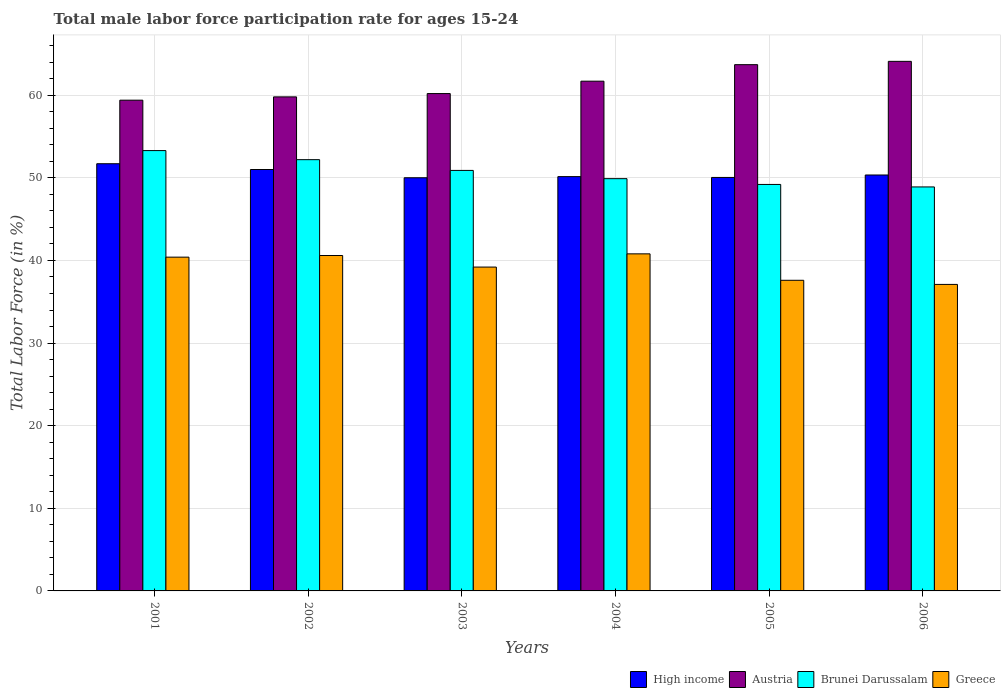How many different coloured bars are there?
Give a very brief answer. 4. How many groups of bars are there?
Offer a terse response. 6. Are the number of bars on each tick of the X-axis equal?
Your response must be concise. Yes. What is the label of the 3rd group of bars from the left?
Provide a short and direct response. 2003. What is the male labor force participation rate in Greece in 2006?
Ensure brevity in your answer.  37.1. Across all years, what is the maximum male labor force participation rate in High income?
Your response must be concise. 51.71. Across all years, what is the minimum male labor force participation rate in High income?
Offer a very short reply. 50.01. What is the total male labor force participation rate in High income in the graph?
Ensure brevity in your answer.  303.27. What is the difference between the male labor force participation rate in Greece in 2003 and that in 2005?
Your answer should be very brief. 1.6. What is the difference between the male labor force participation rate in High income in 2005 and the male labor force participation rate in Greece in 2002?
Your answer should be compact. 9.45. What is the average male labor force participation rate in High income per year?
Provide a short and direct response. 50.54. In the year 2001, what is the difference between the male labor force participation rate in Greece and male labor force participation rate in Brunei Darussalam?
Offer a very short reply. -12.9. In how many years, is the male labor force participation rate in High income greater than 58 %?
Give a very brief answer. 0. What is the ratio of the male labor force participation rate in Greece in 2001 to that in 2003?
Give a very brief answer. 1.03. Is the difference between the male labor force participation rate in Greece in 2001 and 2005 greater than the difference between the male labor force participation rate in Brunei Darussalam in 2001 and 2005?
Your response must be concise. No. What is the difference between the highest and the second highest male labor force participation rate in Brunei Darussalam?
Make the answer very short. 1.1. What is the difference between the highest and the lowest male labor force participation rate in Brunei Darussalam?
Give a very brief answer. 4.4. In how many years, is the male labor force participation rate in Austria greater than the average male labor force participation rate in Austria taken over all years?
Make the answer very short. 3. What does the 4th bar from the left in 2003 represents?
Offer a terse response. Greece. Is it the case that in every year, the sum of the male labor force participation rate in Greece and male labor force participation rate in Brunei Darussalam is greater than the male labor force participation rate in High income?
Your response must be concise. Yes. How many bars are there?
Give a very brief answer. 24. Are all the bars in the graph horizontal?
Offer a very short reply. No. How many years are there in the graph?
Offer a terse response. 6. What is the difference between two consecutive major ticks on the Y-axis?
Your answer should be very brief. 10. Are the values on the major ticks of Y-axis written in scientific E-notation?
Make the answer very short. No. How are the legend labels stacked?
Provide a succinct answer. Horizontal. What is the title of the graph?
Your answer should be very brief. Total male labor force participation rate for ages 15-24. Does "Sub-Saharan Africa (all income levels)" appear as one of the legend labels in the graph?
Your answer should be compact. No. What is the label or title of the Y-axis?
Give a very brief answer. Total Labor Force (in %). What is the Total Labor Force (in %) in High income in 2001?
Offer a very short reply. 51.71. What is the Total Labor Force (in %) of Austria in 2001?
Give a very brief answer. 59.4. What is the Total Labor Force (in %) of Brunei Darussalam in 2001?
Make the answer very short. 53.3. What is the Total Labor Force (in %) of Greece in 2001?
Offer a terse response. 40.4. What is the Total Labor Force (in %) of High income in 2002?
Ensure brevity in your answer.  51.01. What is the Total Labor Force (in %) of Austria in 2002?
Provide a short and direct response. 59.8. What is the Total Labor Force (in %) of Brunei Darussalam in 2002?
Your answer should be compact. 52.2. What is the Total Labor Force (in %) in Greece in 2002?
Provide a succinct answer. 40.6. What is the Total Labor Force (in %) in High income in 2003?
Provide a short and direct response. 50.01. What is the Total Labor Force (in %) of Austria in 2003?
Your answer should be very brief. 60.2. What is the Total Labor Force (in %) of Brunei Darussalam in 2003?
Your answer should be very brief. 50.9. What is the Total Labor Force (in %) in Greece in 2003?
Your response must be concise. 39.2. What is the Total Labor Force (in %) of High income in 2004?
Provide a short and direct response. 50.15. What is the Total Labor Force (in %) in Austria in 2004?
Your response must be concise. 61.7. What is the Total Labor Force (in %) in Brunei Darussalam in 2004?
Make the answer very short. 49.9. What is the Total Labor Force (in %) of Greece in 2004?
Offer a very short reply. 40.8. What is the Total Labor Force (in %) in High income in 2005?
Provide a succinct answer. 50.05. What is the Total Labor Force (in %) in Austria in 2005?
Give a very brief answer. 63.7. What is the Total Labor Force (in %) of Brunei Darussalam in 2005?
Offer a very short reply. 49.2. What is the Total Labor Force (in %) of Greece in 2005?
Your answer should be compact. 37.6. What is the Total Labor Force (in %) of High income in 2006?
Offer a terse response. 50.35. What is the Total Labor Force (in %) of Austria in 2006?
Make the answer very short. 64.1. What is the Total Labor Force (in %) in Brunei Darussalam in 2006?
Ensure brevity in your answer.  48.9. What is the Total Labor Force (in %) of Greece in 2006?
Your answer should be compact. 37.1. Across all years, what is the maximum Total Labor Force (in %) in High income?
Offer a very short reply. 51.71. Across all years, what is the maximum Total Labor Force (in %) of Austria?
Give a very brief answer. 64.1. Across all years, what is the maximum Total Labor Force (in %) in Brunei Darussalam?
Provide a succinct answer. 53.3. Across all years, what is the maximum Total Labor Force (in %) of Greece?
Ensure brevity in your answer.  40.8. Across all years, what is the minimum Total Labor Force (in %) in High income?
Provide a succinct answer. 50.01. Across all years, what is the minimum Total Labor Force (in %) in Austria?
Your answer should be very brief. 59.4. Across all years, what is the minimum Total Labor Force (in %) in Brunei Darussalam?
Offer a terse response. 48.9. Across all years, what is the minimum Total Labor Force (in %) of Greece?
Offer a very short reply. 37.1. What is the total Total Labor Force (in %) of High income in the graph?
Make the answer very short. 303.27. What is the total Total Labor Force (in %) in Austria in the graph?
Provide a short and direct response. 368.9. What is the total Total Labor Force (in %) in Brunei Darussalam in the graph?
Provide a succinct answer. 304.4. What is the total Total Labor Force (in %) in Greece in the graph?
Make the answer very short. 235.7. What is the difference between the Total Labor Force (in %) in High income in 2001 and that in 2002?
Give a very brief answer. 0.7. What is the difference between the Total Labor Force (in %) in High income in 2001 and that in 2003?
Make the answer very short. 1.7. What is the difference between the Total Labor Force (in %) of High income in 2001 and that in 2004?
Your response must be concise. 1.56. What is the difference between the Total Labor Force (in %) in High income in 2001 and that in 2005?
Provide a succinct answer. 1.66. What is the difference between the Total Labor Force (in %) of Brunei Darussalam in 2001 and that in 2005?
Make the answer very short. 4.1. What is the difference between the Total Labor Force (in %) of High income in 2001 and that in 2006?
Keep it short and to the point. 1.36. What is the difference between the Total Labor Force (in %) in Brunei Darussalam in 2001 and that in 2006?
Ensure brevity in your answer.  4.4. What is the difference between the Total Labor Force (in %) of Greece in 2001 and that in 2006?
Provide a short and direct response. 3.3. What is the difference between the Total Labor Force (in %) of High income in 2002 and that in 2004?
Keep it short and to the point. 0.86. What is the difference between the Total Labor Force (in %) in High income in 2002 and that in 2005?
Provide a succinct answer. 0.96. What is the difference between the Total Labor Force (in %) of Greece in 2002 and that in 2005?
Your answer should be very brief. 3. What is the difference between the Total Labor Force (in %) in High income in 2002 and that in 2006?
Provide a succinct answer. 0.66. What is the difference between the Total Labor Force (in %) in Brunei Darussalam in 2002 and that in 2006?
Your answer should be very brief. 3.3. What is the difference between the Total Labor Force (in %) of Greece in 2002 and that in 2006?
Provide a succinct answer. 3.5. What is the difference between the Total Labor Force (in %) of High income in 2003 and that in 2004?
Keep it short and to the point. -0.14. What is the difference between the Total Labor Force (in %) of Austria in 2003 and that in 2004?
Make the answer very short. -1.5. What is the difference between the Total Labor Force (in %) of Greece in 2003 and that in 2004?
Provide a short and direct response. -1.6. What is the difference between the Total Labor Force (in %) in High income in 2003 and that in 2005?
Provide a succinct answer. -0.04. What is the difference between the Total Labor Force (in %) of Austria in 2003 and that in 2005?
Keep it short and to the point. -3.5. What is the difference between the Total Labor Force (in %) of Brunei Darussalam in 2003 and that in 2005?
Your answer should be very brief. 1.7. What is the difference between the Total Labor Force (in %) in High income in 2003 and that in 2006?
Offer a very short reply. -0.33. What is the difference between the Total Labor Force (in %) of Austria in 2003 and that in 2006?
Your response must be concise. -3.9. What is the difference between the Total Labor Force (in %) of Brunei Darussalam in 2003 and that in 2006?
Provide a short and direct response. 2. What is the difference between the Total Labor Force (in %) in High income in 2004 and that in 2005?
Your answer should be very brief. 0.1. What is the difference between the Total Labor Force (in %) of Austria in 2004 and that in 2005?
Your response must be concise. -2. What is the difference between the Total Labor Force (in %) of Greece in 2004 and that in 2005?
Provide a short and direct response. 3.2. What is the difference between the Total Labor Force (in %) of High income in 2004 and that in 2006?
Keep it short and to the point. -0.2. What is the difference between the Total Labor Force (in %) of Brunei Darussalam in 2004 and that in 2006?
Make the answer very short. 1. What is the difference between the Total Labor Force (in %) in Greece in 2004 and that in 2006?
Provide a succinct answer. 3.7. What is the difference between the Total Labor Force (in %) in High income in 2005 and that in 2006?
Offer a very short reply. -0.3. What is the difference between the Total Labor Force (in %) in Austria in 2005 and that in 2006?
Provide a succinct answer. -0.4. What is the difference between the Total Labor Force (in %) of Brunei Darussalam in 2005 and that in 2006?
Your answer should be very brief. 0.3. What is the difference between the Total Labor Force (in %) in Greece in 2005 and that in 2006?
Provide a succinct answer. 0.5. What is the difference between the Total Labor Force (in %) of High income in 2001 and the Total Labor Force (in %) of Austria in 2002?
Your answer should be compact. -8.09. What is the difference between the Total Labor Force (in %) in High income in 2001 and the Total Labor Force (in %) in Brunei Darussalam in 2002?
Keep it short and to the point. -0.49. What is the difference between the Total Labor Force (in %) of High income in 2001 and the Total Labor Force (in %) of Greece in 2002?
Make the answer very short. 11.11. What is the difference between the Total Labor Force (in %) of Austria in 2001 and the Total Labor Force (in %) of Brunei Darussalam in 2002?
Provide a succinct answer. 7.2. What is the difference between the Total Labor Force (in %) in Brunei Darussalam in 2001 and the Total Labor Force (in %) in Greece in 2002?
Give a very brief answer. 12.7. What is the difference between the Total Labor Force (in %) in High income in 2001 and the Total Labor Force (in %) in Austria in 2003?
Offer a very short reply. -8.49. What is the difference between the Total Labor Force (in %) in High income in 2001 and the Total Labor Force (in %) in Brunei Darussalam in 2003?
Your response must be concise. 0.81. What is the difference between the Total Labor Force (in %) of High income in 2001 and the Total Labor Force (in %) of Greece in 2003?
Provide a short and direct response. 12.51. What is the difference between the Total Labor Force (in %) of Austria in 2001 and the Total Labor Force (in %) of Greece in 2003?
Make the answer very short. 20.2. What is the difference between the Total Labor Force (in %) of High income in 2001 and the Total Labor Force (in %) of Austria in 2004?
Provide a succinct answer. -9.99. What is the difference between the Total Labor Force (in %) in High income in 2001 and the Total Labor Force (in %) in Brunei Darussalam in 2004?
Your answer should be very brief. 1.81. What is the difference between the Total Labor Force (in %) of High income in 2001 and the Total Labor Force (in %) of Greece in 2004?
Give a very brief answer. 10.91. What is the difference between the Total Labor Force (in %) in Brunei Darussalam in 2001 and the Total Labor Force (in %) in Greece in 2004?
Your answer should be compact. 12.5. What is the difference between the Total Labor Force (in %) of High income in 2001 and the Total Labor Force (in %) of Austria in 2005?
Keep it short and to the point. -11.99. What is the difference between the Total Labor Force (in %) in High income in 2001 and the Total Labor Force (in %) in Brunei Darussalam in 2005?
Your answer should be very brief. 2.51. What is the difference between the Total Labor Force (in %) in High income in 2001 and the Total Labor Force (in %) in Greece in 2005?
Provide a short and direct response. 14.11. What is the difference between the Total Labor Force (in %) of Austria in 2001 and the Total Labor Force (in %) of Brunei Darussalam in 2005?
Offer a very short reply. 10.2. What is the difference between the Total Labor Force (in %) in Austria in 2001 and the Total Labor Force (in %) in Greece in 2005?
Offer a very short reply. 21.8. What is the difference between the Total Labor Force (in %) of Brunei Darussalam in 2001 and the Total Labor Force (in %) of Greece in 2005?
Give a very brief answer. 15.7. What is the difference between the Total Labor Force (in %) in High income in 2001 and the Total Labor Force (in %) in Austria in 2006?
Make the answer very short. -12.39. What is the difference between the Total Labor Force (in %) in High income in 2001 and the Total Labor Force (in %) in Brunei Darussalam in 2006?
Offer a terse response. 2.81. What is the difference between the Total Labor Force (in %) in High income in 2001 and the Total Labor Force (in %) in Greece in 2006?
Give a very brief answer. 14.61. What is the difference between the Total Labor Force (in %) of Austria in 2001 and the Total Labor Force (in %) of Greece in 2006?
Offer a very short reply. 22.3. What is the difference between the Total Labor Force (in %) of High income in 2002 and the Total Labor Force (in %) of Austria in 2003?
Offer a very short reply. -9.19. What is the difference between the Total Labor Force (in %) of High income in 2002 and the Total Labor Force (in %) of Brunei Darussalam in 2003?
Keep it short and to the point. 0.11. What is the difference between the Total Labor Force (in %) of High income in 2002 and the Total Labor Force (in %) of Greece in 2003?
Provide a short and direct response. 11.81. What is the difference between the Total Labor Force (in %) of Austria in 2002 and the Total Labor Force (in %) of Greece in 2003?
Make the answer very short. 20.6. What is the difference between the Total Labor Force (in %) of High income in 2002 and the Total Labor Force (in %) of Austria in 2004?
Keep it short and to the point. -10.69. What is the difference between the Total Labor Force (in %) in High income in 2002 and the Total Labor Force (in %) in Brunei Darussalam in 2004?
Offer a terse response. 1.11. What is the difference between the Total Labor Force (in %) in High income in 2002 and the Total Labor Force (in %) in Greece in 2004?
Make the answer very short. 10.21. What is the difference between the Total Labor Force (in %) of High income in 2002 and the Total Labor Force (in %) of Austria in 2005?
Keep it short and to the point. -12.69. What is the difference between the Total Labor Force (in %) in High income in 2002 and the Total Labor Force (in %) in Brunei Darussalam in 2005?
Ensure brevity in your answer.  1.81. What is the difference between the Total Labor Force (in %) in High income in 2002 and the Total Labor Force (in %) in Greece in 2005?
Offer a very short reply. 13.41. What is the difference between the Total Labor Force (in %) in Austria in 2002 and the Total Labor Force (in %) in Brunei Darussalam in 2005?
Ensure brevity in your answer.  10.6. What is the difference between the Total Labor Force (in %) in Brunei Darussalam in 2002 and the Total Labor Force (in %) in Greece in 2005?
Give a very brief answer. 14.6. What is the difference between the Total Labor Force (in %) in High income in 2002 and the Total Labor Force (in %) in Austria in 2006?
Your response must be concise. -13.09. What is the difference between the Total Labor Force (in %) in High income in 2002 and the Total Labor Force (in %) in Brunei Darussalam in 2006?
Keep it short and to the point. 2.11. What is the difference between the Total Labor Force (in %) of High income in 2002 and the Total Labor Force (in %) of Greece in 2006?
Offer a very short reply. 13.91. What is the difference between the Total Labor Force (in %) in Austria in 2002 and the Total Labor Force (in %) in Greece in 2006?
Make the answer very short. 22.7. What is the difference between the Total Labor Force (in %) in Brunei Darussalam in 2002 and the Total Labor Force (in %) in Greece in 2006?
Your answer should be compact. 15.1. What is the difference between the Total Labor Force (in %) of High income in 2003 and the Total Labor Force (in %) of Austria in 2004?
Make the answer very short. -11.69. What is the difference between the Total Labor Force (in %) of High income in 2003 and the Total Labor Force (in %) of Brunei Darussalam in 2004?
Provide a succinct answer. 0.11. What is the difference between the Total Labor Force (in %) in High income in 2003 and the Total Labor Force (in %) in Greece in 2004?
Offer a terse response. 9.21. What is the difference between the Total Labor Force (in %) of Austria in 2003 and the Total Labor Force (in %) of Brunei Darussalam in 2004?
Provide a succinct answer. 10.3. What is the difference between the Total Labor Force (in %) of High income in 2003 and the Total Labor Force (in %) of Austria in 2005?
Provide a succinct answer. -13.69. What is the difference between the Total Labor Force (in %) of High income in 2003 and the Total Labor Force (in %) of Brunei Darussalam in 2005?
Your answer should be very brief. 0.81. What is the difference between the Total Labor Force (in %) in High income in 2003 and the Total Labor Force (in %) in Greece in 2005?
Your answer should be compact. 12.41. What is the difference between the Total Labor Force (in %) of Austria in 2003 and the Total Labor Force (in %) of Greece in 2005?
Ensure brevity in your answer.  22.6. What is the difference between the Total Labor Force (in %) of High income in 2003 and the Total Labor Force (in %) of Austria in 2006?
Keep it short and to the point. -14.09. What is the difference between the Total Labor Force (in %) of High income in 2003 and the Total Labor Force (in %) of Brunei Darussalam in 2006?
Provide a short and direct response. 1.11. What is the difference between the Total Labor Force (in %) of High income in 2003 and the Total Labor Force (in %) of Greece in 2006?
Offer a terse response. 12.91. What is the difference between the Total Labor Force (in %) of Austria in 2003 and the Total Labor Force (in %) of Greece in 2006?
Offer a terse response. 23.1. What is the difference between the Total Labor Force (in %) in Brunei Darussalam in 2003 and the Total Labor Force (in %) in Greece in 2006?
Keep it short and to the point. 13.8. What is the difference between the Total Labor Force (in %) in High income in 2004 and the Total Labor Force (in %) in Austria in 2005?
Offer a terse response. -13.55. What is the difference between the Total Labor Force (in %) of High income in 2004 and the Total Labor Force (in %) of Brunei Darussalam in 2005?
Your answer should be very brief. 0.95. What is the difference between the Total Labor Force (in %) of High income in 2004 and the Total Labor Force (in %) of Greece in 2005?
Offer a terse response. 12.55. What is the difference between the Total Labor Force (in %) in Austria in 2004 and the Total Labor Force (in %) in Brunei Darussalam in 2005?
Your response must be concise. 12.5. What is the difference between the Total Labor Force (in %) in Austria in 2004 and the Total Labor Force (in %) in Greece in 2005?
Keep it short and to the point. 24.1. What is the difference between the Total Labor Force (in %) in High income in 2004 and the Total Labor Force (in %) in Austria in 2006?
Your answer should be very brief. -13.95. What is the difference between the Total Labor Force (in %) in High income in 2004 and the Total Labor Force (in %) in Brunei Darussalam in 2006?
Offer a very short reply. 1.25. What is the difference between the Total Labor Force (in %) of High income in 2004 and the Total Labor Force (in %) of Greece in 2006?
Your answer should be very brief. 13.05. What is the difference between the Total Labor Force (in %) in Austria in 2004 and the Total Labor Force (in %) in Brunei Darussalam in 2006?
Provide a succinct answer. 12.8. What is the difference between the Total Labor Force (in %) in Austria in 2004 and the Total Labor Force (in %) in Greece in 2006?
Your answer should be compact. 24.6. What is the difference between the Total Labor Force (in %) in High income in 2005 and the Total Labor Force (in %) in Austria in 2006?
Keep it short and to the point. -14.05. What is the difference between the Total Labor Force (in %) in High income in 2005 and the Total Labor Force (in %) in Brunei Darussalam in 2006?
Provide a short and direct response. 1.15. What is the difference between the Total Labor Force (in %) of High income in 2005 and the Total Labor Force (in %) of Greece in 2006?
Your answer should be compact. 12.95. What is the difference between the Total Labor Force (in %) of Austria in 2005 and the Total Labor Force (in %) of Greece in 2006?
Ensure brevity in your answer.  26.6. What is the difference between the Total Labor Force (in %) in Brunei Darussalam in 2005 and the Total Labor Force (in %) in Greece in 2006?
Offer a very short reply. 12.1. What is the average Total Labor Force (in %) in High income per year?
Keep it short and to the point. 50.54. What is the average Total Labor Force (in %) in Austria per year?
Your answer should be compact. 61.48. What is the average Total Labor Force (in %) in Brunei Darussalam per year?
Provide a short and direct response. 50.73. What is the average Total Labor Force (in %) of Greece per year?
Offer a terse response. 39.28. In the year 2001, what is the difference between the Total Labor Force (in %) in High income and Total Labor Force (in %) in Austria?
Provide a short and direct response. -7.69. In the year 2001, what is the difference between the Total Labor Force (in %) of High income and Total Labor Force (in %) of Brunei Darussalam?
Give a very brief answer. -1.59. In the year 2001, what is the difference between the Total Labor Force (in %) in High income and Total Labor Force (in %) in Greece?
Ensure brevity in your answer.  11.31. In the year 2001, what is the difference between the Total Labor Force (in %) in Brunei Darussalam and Total Labor Force (in %) in Greece?
Offer a very short reply. 12.9. In the year 2002, what is the difference between the Total Labor Force (in %) in High income and Total Labor Force (in %) in Austria?
Keep it short and to the point. -8.79. In the year 2002, what is the difference between the Total Labor Force (in %) in High income and Total Labor Force (in %) in Brunei Darussalam?
Offer a very short reply. -1.19. In the year 2002, what is the difference between the Total Labor Force (in %) of High income and Total Labor Force (in %) of Greece?
Keep it short and to the point. 10.41. In the year 2002, what is the difference between the Total Labor Force (in %) in Brunei Darussalam and Total Labor Force (in %) in Greece?
Provide a succinct answer. 11.6. In the year 2003, what is the difference between the Total Labor Force (in %) in High income and Total Labor Force (in %) in Austria?
Offer a very short reply. -10.19. In the year 2003, what is the difference between the Total Labor Force (in %) of High income and Total Labor Force (in %) of Brunei Darussalam?
Your answer should be very brief. -0.89. In the year 2003, what is the difference between the Total Labor Force (in %) of High income and Total Labor Force (in %) of Greece?
Provide a succinct answer. 10.81. In the year 2003, what is the difference between the Total Labor Force (in %) in Austria and Total Labor Force (in %) in Greece?
Your answer should be compact. 21. In the year 2004, what is the difference between the Total Labor Force (in %) in High income and Total Labor Force (in %) in Austria?
Give a very brief answer. -11.55. In the year 2004, what is the difference between the Total Labor Force (in %) of High income and Total Labor Force (in %) of Brunei Darussalam?
Ensure brevity in your answer.  0.25. In the year 2004, what is the difference between the Total Labor Force (in %) of High income and Total Labor Force (in %) of Greece?
Offer a very short reply. 9.35. In the year 2004, what is the difference between the Total Labor Force (in %) of Austria and Total Labor Force (in %) of Brunei Darussalam?
Your response must be concise. 11.8. In the year 2004, what is the difference between the Total Labor Force (in %) in Austria and Total Labor Force (in %) in Greece?
Your response must be concise. 20.9. In the year 2004, what is the difference between the Total Labor Force (in %) of Brunei Darussalam and Total Labor Force (in %) of Greece?
Offer a very short reply. 9.1. In the year 2005, what is the difference between the Total Labor Force (in %) in High income and Total Labor Force (in %) in Austria?
Ensure brevity in your answer.  -13.65. In the year 2005, what is the difference between the Total Labor Force (in %) of High income and Total Labor Force (in %) of Brunei Darussalam?
Your response must be concise. 0.85. In the year 2005, what is the difference between the Total Labor Force (in %) of High income and Total Labor Force (in %) of Greece?
Give a very brief answer. 12.45. In the year 2005, what is the difference between the Total Labor Force (in %) in Austria and Total Labor Force (in %) in Greece?
Your answer should be compact. 26.1. In the year 2006, what is the difference between the Total Labor Force (in %) of High income and Total Labor Force (in %) of Austria?
Offer a terse response. -13.75. In the year 2006, what is the difference between the Total Labor Force (in %) of High income and Total Labor Force (in %) of Brunei Darussalam?
Give a very brief answer. 1.45. In the year 2006, what is the difference between the Total Labor Force (in %) of High income and Total Labor Force (in %) of Greece?
Give a very brief answer. 13.25. In the year 2006, what is the difference between the Total Labor Force (in %) in Austria and Total Labor Force (in %) in Brunei Darussalam?
Provide a succinct answer. 15.2. In the year 2006, what is the difference between the Total Labor Force (in %) of Austria and Total Labor Force (in %) of Greece?
Your answer should be very brief. 27. In the year 2006, what is the difference between the Total Labor Force (in %) in Brunei Darussalam and Total Labor Force (in %) in Greece?
Provide a short and direct response. 11.8. What is the ratio of the Total Labor Force (in %) of High income in 2001 to that in 2002?
Give a very brief answer. 1.01. What is the ratio of the Total Labor Force (in %) in Austria in 2001 to that in 2002?
Give a very brief answer. 0.99. What is the ratio of the Total Labor Force (in %) in Brunei Darussalam in 2001 to that in 2002?
Ensure brevity in your answer.  1.02. What is the ratio of the Total Labor Force (in %) in High income in 2001 to that in 2003?
Your answer should be compact. 1.03. What is the ratio of the Total Labor Force (in %) of Austria in 2001 to that in 2003?
Provide a short and direct response. 0.99. What is the ratio of the Total Labor Force (in %) of Brunei Darussalam in 2001 to that in 2003?
Keep it short and to the point. 1.05. What is the ratio of the Total Labor Force (in %) in Greece in 2001 to that in 2003?
Provide a succinct answer. 1.03. What is the ratio of the Total Labor Force (in %) in High income in 2001 to that in 2004?
Provide a short and direct response. 1.03. What is the ratio of the Total Labor Force (in %) in Austria in 2001 to that in 2004?
Ensure brevity in your answer.  0.96. What is the ratio of the Total Labor Force (in %) in Brunei Darussalam in 2001 to that in 2004?
Offer a very short reply. 1.07. What is the ratio of the Total Labor Force (in %) of Greece in 2001 to that in 2004?
Your answer should be compact. 0.99. What is the ratio of the Total Labor Force (in %) of High income in 2001 to that in 2005?
Provide a succinct answer. 1.03. What is the ratio of the Total Labor Force (in %) in Austria in 2001 to that in 2005?
Ensure brevity in your answer.  0.93. What is the ratio of the Total Labor Force (in %) of Greece in 2001 to that in 2005?
Offer a very short reply. 1.07. What is the ratio of the Total Labor Force (in %) in High income in 2001 to that in 2006?
Offer a very short reply. 1.03. What is the ratio of the Total Labor Force (in %) of Austria in 2001 to that in 2006?
Your answer should be compact. 0.93. What is the ratio of the Total Labor Force (in %) in Brunei Darussalam in 2001 to that in 2006?
Provide a succinct answer. 1.09. What is the ratio of the Total Labor Force (in %) in Greece in 2001 to that in 2006?
Keep it short and to the point. 1.09. What is the ratio of the Total Labor Force (in %) in High income in 2002 to that in 2003?
Keep it short and to the point. 1.02. What is the ratio of the Total Labor Force (in %) of Brunei Darussalam in 2002 to that in 2003?
Ensure brevity in your answer.  1.03. What is the ratio of the Total Labor Force (in %) in Greece in 2002 to that in 2003?
Provide a short and direct response. 1.04. What is the ratio of the Total Labor Force (in %) of High income in 2002 to that in 2004?
Keep it short and to the point. 1.02. What is the ratio of the Total Labor Force (in %) of Austria in 2002 to that in 2004?
Keep it short and to the point. 0.97. What is the ratio of the Total Labor Force (in %) in Brunei Darussalam in 2002 to that in 2004?
Offer a terse response. 1.05. What is the ratio of the Total Labor Force (in %) in Greece in 2002 to that in 2004?
Give a very brief answer. 1. What is the ratio of the Total Labor Force (in %) in High income in 2002 to that in 2005?
Ensure brevity in your answer.  1.02. What is the ratio of the Total Labor Force (in %) in Austria in 2002 to that in 2005?
Offer a terse response. 0.94. What is the ratio of the Total Labor Force (in %) of Brunei Darussalam in 2002 to that in 2005?
Provide a succinct answer. 1.06. What is the ratio of the Total Labor Force (in %) of Greece in 2002 to that in 2005?
Your answer should be compact. 1.08. What is the ratio of the Total Labor Force (in %) in High income in 2002 to that in 2006?
Ensure brevity in your answer.  1.01. What is the ratio of the Total Labor Force (in %) in Austria in 2002 to that in 2006?
Offer a terse response. 0.93. What is the ratio of the Total Labor Force (in %) of Brunei Darussalam in 2002 to that in 2006?
Provide a short and direct response. 1.07. What is the ratio of the Total Labor Force (in %) in Greece in 2002 to that in 2006?
Your answer should be compact. 1.09. What is the ratio of the Total Labor Force (in %) of Austria in 2003 to that in 2004?
Provide a succinct answer. 0.98. What is the ratio of the Total Labor Force (in %) in Greece in 2003 to that in 2004?
Give a very brief answer. 0.96. What is the ratio of the Total Labor Force (in %) in High income in 2003 to that in 2005?
Keep it short and to the point. 1. What is the ratio of the Total Labor Force (in %) of Austria in 2003 to that in 2005?
Your response must be concise. 0.95. What is the ratio of the Total Labor Force (in %) in Brunei Darussalam in 2003 to that in 2005?
Offer a terse response. 1.03. What is the ratio of the Total Labor Force (in %) in Greece in 2003 to that in 2005?
Keep it short and to the point. 1.04. What is the ratio of the Total Labor Force (in %) of Austria in 2003 to that in 2006?
Offer a terse response. 0.94. What is the ratio of the Total Labor Force (in %) in Brunei Darussalam in 2003 to that in 2006?
Provide a succinct answer. 1.04. What is the ratio of the Total Labor Force (in %) in Greece in 2003 to that in 2006?
Keep it short and to the point. 1.06. What is the ratio of the Total Labor Force (in %) of Austria in 2004 to that in 2005?
Make the answer very short. 0.97. What is the ratio of the Total Labor Force (in %) of Brunei Darussalam in 2004 to that in 2005?
Make the answer very short. 1.01. What is the ratio of the Total Labor Force (in %) of Greece in 2004 to that in 2005?
Offer a very short reply. 1.09. What is the ratio of the Total Labor Force (in %) of High income in 2004 to that in 2006?
Provide a succinct answer. 1. What is the ratio of the Total Labor Force (in %) of Austria in 2004 to that in 2006?
Offer a terse response. 0.96. What is the ratio of the Total Labor Force (in %) in Brunei Darussalam in 2004 to that in 2006?
Your answer should be very brief. 1.02. What is the ratio of the Total Labor Force (in %) of Greece in 2004 to that in 2006?
Your response must be concise. 1.1. What is the ratio of the Total Labor Force (in %) in High income in 2005 to that in 2006?
Give a very brief answer. 0.99. What is the ratio of the Total Labor Force (in %) in Austria in 2005 to that in 2006?
Offer a very short reply. 0.99. What is the ratio of the Total Labor Force (in %) in Greece in 2005 to that in 2006?
Keep it short and to the point. 1.01. What is the difference between the highest and the second highest Total Labor Force (in %) in High income?
Your answer should be very brief. 0.7. What is the difference between the highest and the second highest Total Labor Force (in %) of Austria?
Ensure brevity in your answer.  0.4. What is the difference between the highest and the second highest Total Labor Force (in %) of Greece?
Ensure brevity in your answer.  0.2. What is the difference between the highest and the lowest Total Labor Force (in %) of High income?
Provide a succinct answer. 1.7. What is the difference between the highest and the lowest Total Labor Force (in %) in Brunei Darussalam?
Offer a terse response. 4.4. 